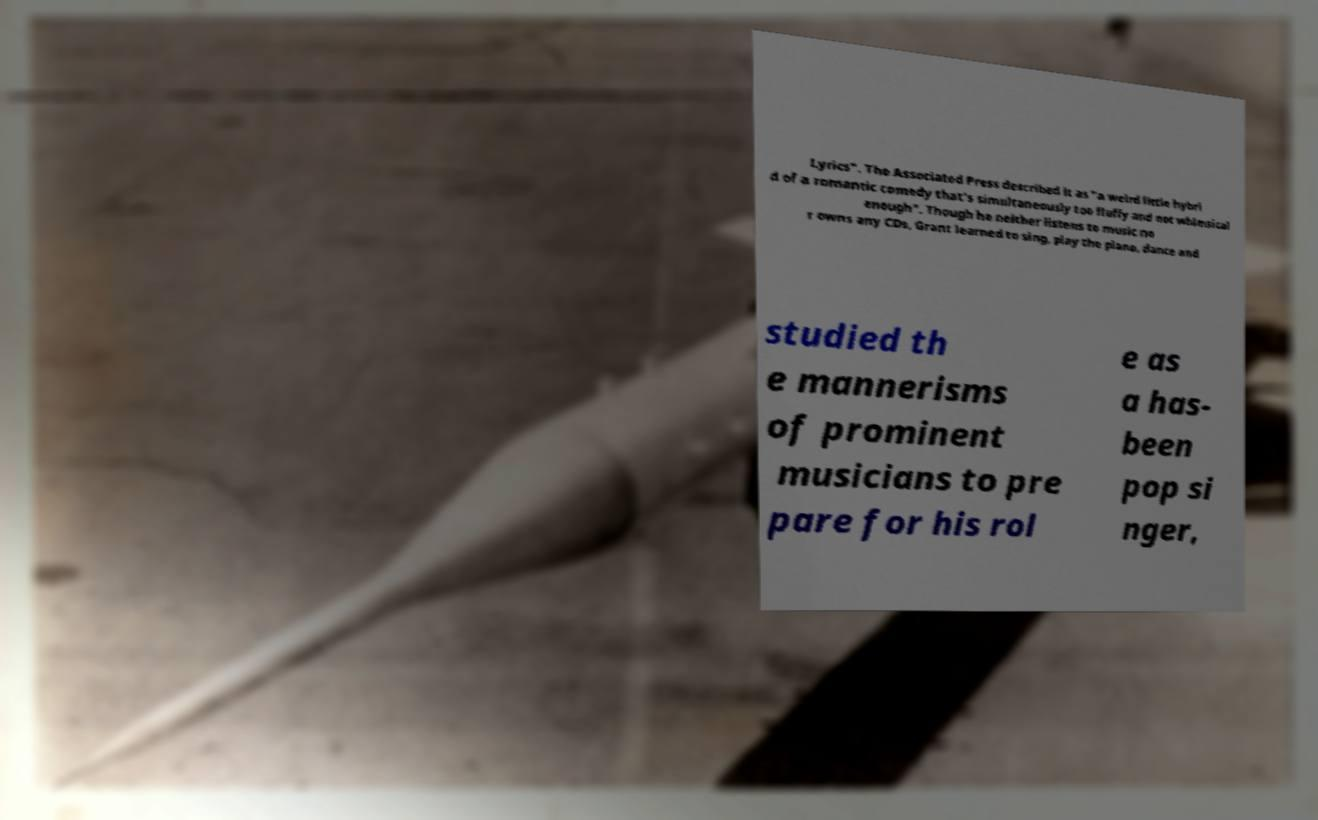What messages or text are displayed in this image? I need them in a readable, typed format. Lyrics". The Associated Press described it as "a weird little hybri d of a romantic comedy that's simultaneously too fluffy and not whimsical enough". Though he neither listens to music no r owns any CDs, Grant learned to sing, play the piano, dance and studied th e mannerisms of prominent musicians to pre pare for his rol e as a has- been pop si nger, 